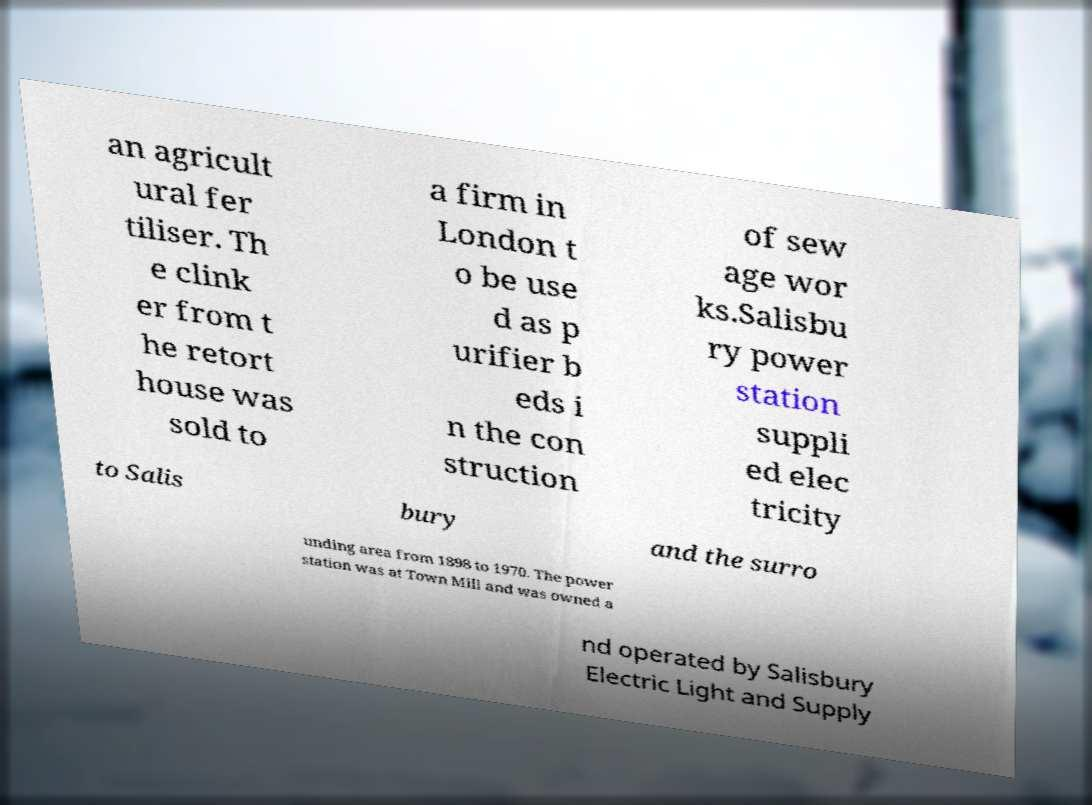There's text embedded in this image that I need extracted. Can you transcribe it verbatim? an agricult ural fer tiliser. Th e clink er from t he retort house was sold to a firm in London t o be use d as p urifier b eds i n the con struction of sew age wor ks.Salisbu ry power station suppli ed elec tricity to Salis bury and the surro unding area from 1898 to 1970. The power station was at Town Mill and was owned a nd operated by Salisbury Electric Light and Supply 